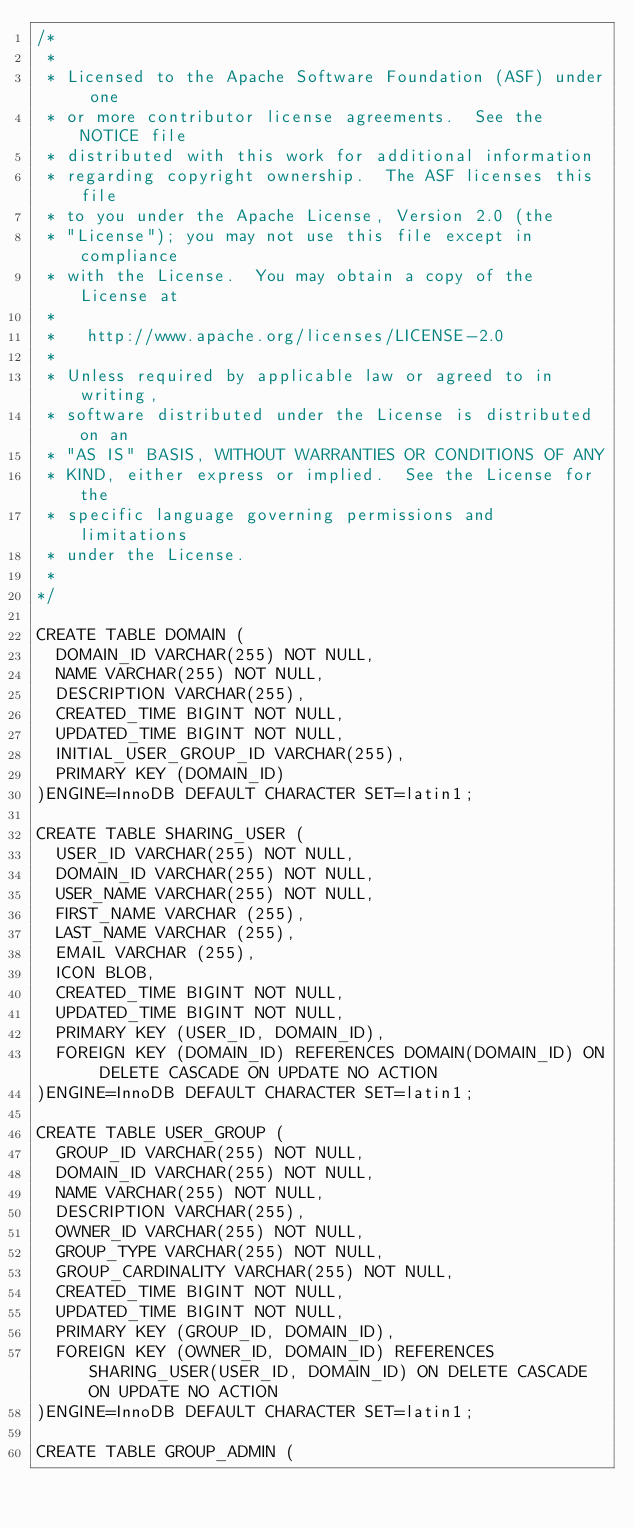Convert code to text. <code><loc_0><loc_0><loc_500><loc_500><_SQL_>/*
 *
 * Licensed to the Apache Software Foundation (ASF) under one
 * or more contributor license agreements.  See the NOTICE file
 * distributed with this work for additional information
 * regarding copyright ownership.  The ASF licenses this file
 * to you under the Apache License, Version 2.0 (the
 * "License"); you may not use this file except in compliance
 * with the License.  You may obtain a copy of the License at
 *
 *   http://www.apache.org/licenses/LICENSE-2.0
 *
 * Unless required by applicable law or agreed to in writing,
 * software distributed under the License is distributed on an
 * "AS IS" BASIS, WITHOUT WARRANTIES OR CONDITIONS OF ANY
 * KIND, either express or implied.  See the License for the
 * specific language governing permissions and limitations
 * under the License.
 *
*/

CREATE TABLE DOMAIN (
  DOMAIN_ID VARCHAR(255) NOT NULL,
  NAME VARCHAR(255) NOT NULL,
  DESCRIPTION VARCHAR(255),
  CREATED_TIME BIGINT NOT NULL,
  UPDATED_TIME BIGINT NOT NULL,
  INITIAL_USER_GROUP_ID VARCHAR(255),
  PRIMARY KEY (DOMAIN_ID)
)ENGINE=InnoDB DEFAULT CHARACTER SET=latin1;

CREATE TABLE SHARING_USER (
  USER_ID VARCHAR(255) NOT NULL,
  DOMAIN_ID VARCHAR(255) NOT NULL,
  USER_NAME VARCHAR(255) NOT NULL,
  FIRST_NAME VARCHAR (255),
  LAST_NAME VARCHAR (255),
  EMAIL VARCHAR (255),
  ICON BLOB,
  CREATED_TIME BIGINT NOT NULL,
  UPDATED_TIME BIGINT NOT NULL,
  PRIMARY KEY (USER_ID, DOMAIN_ID),
  FOREIGN KEY (DOMAIN_ID) REFERENCES DOMAIN(DOMAIN_ID) ON DELETE CASCADE ON UPDATE NO ACTION
)ENGINE=InnoDB DEFAULT CHARACTER SET=latin1;

CREATE TABLE USER_GROUP (
  GROUP_ID VARCHAR(255) NOT NULL,
  DOMAIN_ID VARCHAR(255) NOT NULL,
  NAME VARCHAR(255) NOT NULL,
  DESCRIPTION VARCHAR(255),
  OWNER_ID VARCHAR(255) NOT NULL,
  GROUP_TYPE VARCHAR(255) NOT NULL,
  GROUP_CARDINALITY VARCHAR(255) NOT NULL,
  CREATED_TIME BIGINT NOT NULL,
  UPDATED_TIME BIGINT NOT NULL,
  PRIMARY KEY (GROUP_ID, DOMAIN_ID),
  FOREIGN KEY (OWNER_ID, DOMAIN_ID) REFERENCES SHARING_USER(USER_ID, DOMAIN_ID) ON DELETE CASCADE ON UPDATE NO ACTION
)ENGINE=InnoDB DEFAULT CHARACTER SET=latin1;

CREATE TABLE GROUP_ADMIN (</code> 